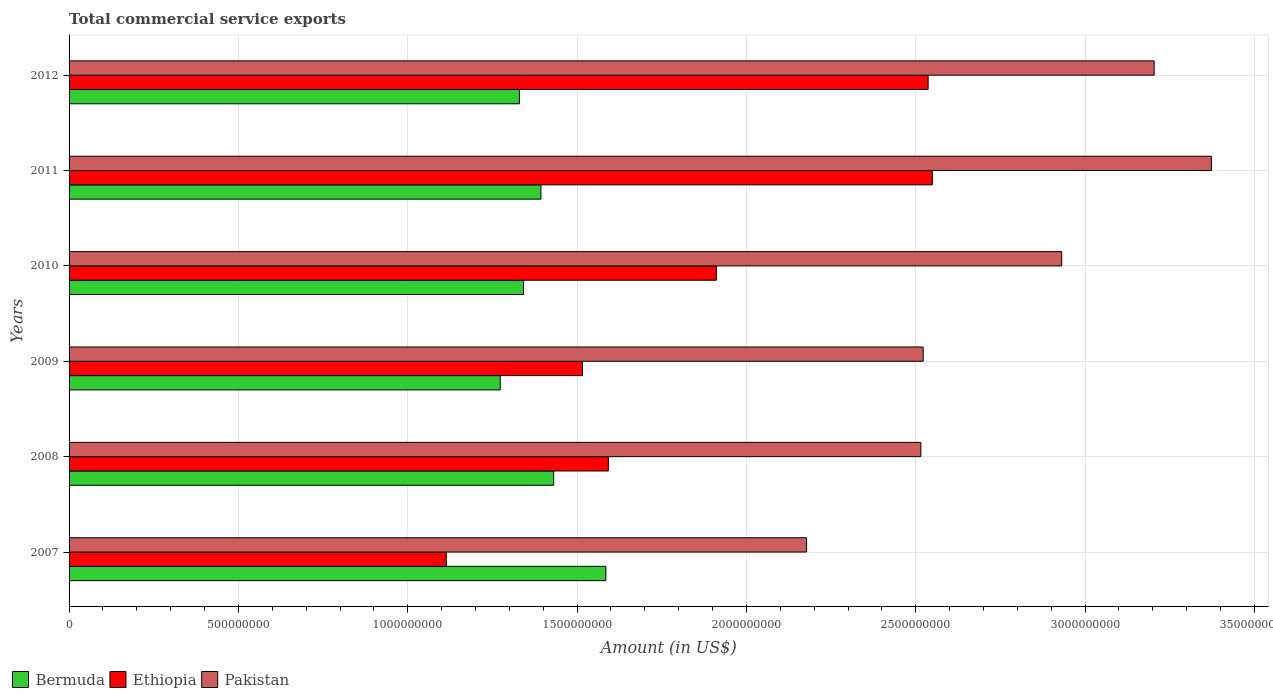How many different coloured bars are there?
Make the answer very short. 3. Are the number of bars per tick equal to the number of legend labels?
Your response must be concise. Yes. How many bars are there on the 2nd tick from the bottom?
Your response must be concise. 3. In how many cases, is the number of bars for a given year not equal to the number of legend labels?
Keep it short and to the point. 0. What is the total commercial service exports in Ethiopia in 2012?
Your answer should be compact. 2.54e+09. Across all years, what is the maximum total commercial service exports in Ethiopia?
Your response must be concise. 2.55e+09. Across all years, what is the minimum total commercial service exports in Ethiopia?
Give a very brief answer. 1.11e+09. What is the total total commercial service exports in Bermuda in the graph?
Your answer should be very brief. 8.35e+09. What is the difference between the total commercial service exports in Bermuda in 2010 and that in 2012?
Provide a short and direct response. 1.20e+07. What is the difference between the total commercial service exports in Ethiopia in 2010 and the total commercial service exports in Pakistan in 2011?
Offer a very short reply. -1.46e+09. What is the average total commercial service exports in Pakistan per year?
Offer a very short reply. 2.79e+09. In the year 2008, what is the difference between the total commercial service exports in Ethiopia and total commercial service exports in Bermuda?
Provide a short and direct response. 1.62e+08. What is the ratio of the total commercial service exports in Bermuda in 2009 to that in 2010?
Make the answer very short. 0.95. Is the difference between the total commercial service exports in Ethiopia in 2008 and 2009 greater than the difference between the total commercial service exports in Bermuda in 2008 and 2009?
Offer a very short reply. No. What is the difference between the highest and the second highest total commercial service exports in Ethiopia?
Provide a succinct answer. 1.24e+07. What is the difference between the highest and the lowest total commercial service exports in Bermuda?
Your answer should be compact. 3.12e+08. What does the 2nd bar from the top in 2008 represents?
Provide a succinct answer. Ethiopia. How many bars are there?
Provide a succinct answer. 18. Are all the bars in the graph horizontal?
Give a very brief answer. Yes. What is the difference between two consecutive major ticks on the X-axis?
Ensure brevity in your answer.  5.00e+08. Are the values on the major ticks of X-axis written in scientific E-notation?
Provide a short and direct response. No. Does the graph contain grids?
Make the answer very short. Yes. Where does the legend appear in the graph?
Make the answer very short. Bottom left. What is the title of the graph?
Offer a very short reply. Total commercial service exports. What is the Amount (in US$) of Bermuda in 2007?
Make the answer very short. 1.58e+09. What is the Amount (in US$) of Ethiopia in 2007?
Your answer should be very brief. 1.11e+09. What is the Amount (in US$) of Pakistan in 2007?
Ensure brevity in your answer.  2.18e+09. What is the Amount (in US$) of Bermuda in 2008?
Give a very brief answer. 1.43e+09. What is the Amount (in US$) in Ethiopia in 2008?
Offer a terse response. 1.59e+09. What is the Amount (in US$) of Pakistan in 2008?
Make the answer very short. 2.52e+09. What is the Amount (in US$) in Bermuda in 2009?
Your answer should be very brief. 1.27e+09. What is the Amount (in US$) of Ethiopia in 2009?
Keep it short and to the point. 1.52e+09. What is the Amount (in US$) of Pakistan in 2009?
Provide a short and direct response. 2.52e+09. What is the Amount (in US$) of Bermuda in 2010?
Your response must be concise. 1.34e+09. What is the Amount (in US$) of Ethiopia in 2010?
Give a very brief answer. 1.91e+09. What is the Amount (in US$) in Pakistan in 2010?
Your answer should be compact. 2.93e+09. What is the Amount (in US$) of Bermuda in 2011?
Give a very brief answer. 1.39e+09. What is the Amount (in US$) in Ethiopia in 2011?
Give a very brief answer. 2.55e+09. What is the Amount (in US$) of Pakistan in 2011?
Make the answer very short. 3.37e+09. What is the Amount (in US$) in Bermuda in 2012?
Ensure brevity in your answer.  1.33e+09. What is the Amount (in US$) of Ethiopia in 2012?
Ensure brevity in your answer.  2.54e+09. What is the Amount (in US$) of Pakistan in 2012?
Your answer should be compact. 3.20e+09. Across all years, what is the maximum Amount (in US$) in Bermuda?
Your answer should be compact. 1.58e+09. Across all years, what is the maximum Amount (in US$) in Ethiopia?
Your response must be concise. 2.55e+09. Across all years, what is the maximum Amount (in US$) in Pakistan?
Your answer should be compact. 3.37e+09. Across all years, what is the minimum Amount (in US$) in Bermuda?
Provide a succinct answer. 1.27e+09. Across all years, what is the minimum Amount (in US$) in Ethiopia?
Offer a very short reply. 1.11e+09. Across all years, what is the minimum Amount (in US$) of Pakistan?
Your answer should be compact. 2.18e+09. What is the total Amount (in US$) of Bermuda in the graph?
Your answer should be very brief. 8.35e+09. What is the total Amount (in US$) of Ethiopia in the graph?
Make the answer very short. 1.12e+1. What is the total Amount (in US$) of Pakistan in the graph?
Make the answer very short. 1.67e+1. What is the difference between the Amount (in US$) in Bermuda in 2007 and that in 2008?
Ensure brevity in your answer.  1.54e+08. What is the difference between the Amount (in US$) of Ethiopia in 2007 and that in 2008?
Your answer should be very brief. -4.79e+08. What is the difference between the Amount (in US$) of Pakistan in 2007 and that in 2008?
Provide a succinct answer. -3.37e+08. What is the difference between the Amount (in US$) in Bermuda in 2007 and that in 2009?
Your response must be concise. 3.12e+08. What is the difference between the Amount (in US$) of Ethiopia in 2007 and that in 2009?
Your response must be concise. -4.02e+08. What is the difference between the Amount (in US$) of Pakistan in 2007 and that in 2009?
Provide a short and direct response. -3.44e+08. What is the difference between the Amount (in US$) in Bermuda in 2007 and that in 2010?
Offer a terse response. 2.43e+08. What is the difference between the Amount (in US$) in Ethiopia in 2007 and that in 2010?
Your answer should be compact. -7.98e+08. What is the difference between the Amount (in US$) in Pakistan in 2007 and that in 2010?
Offer a terse response. -7.53e+08. What is the difference between the Amount (in US$) in Bermuda in 2007 and that in 2011?
Offer a terse response. 1.92e+08. What is the difference between the Amount (in US$) in Ethiopia in 2007 and that in 2011?
Offer a terse response. -1.44e+09. What is the difference between the Amount (in US$) in Pakistan in 2007 and that in 2011?
Make the answer very short. -1.20e+09. What is the difference between the Amount (in US$) in Bermuda in 2007 and that in 2012?
Provide a short and direct response. 2.55e+08. What is the difference between the Amount (in US$) of Ethiopia in 2007 and that in 2012?
Provide a succinct answer. -1.42e+09. What is the difference between the Amount (in US$) in Pakistan in 2007 and that in 2012?
Your response must be concise. -1.03e+09. What is the difference between the Amount (in US$) of Bermuda in 2008 and that in 2009?
Offer a very short reply. 1.58e+08. What is the difference between the Amount (in US$) of Ethiopia in 2008 and that in 2009?
Provide a succinct answer. 7.64e+07. What is the difference between the Amount (in US$) of Pakistan in 2008 and that in 2009?
Offer a terse response. -7.00e+06. What is the difference between the Amount (in US$) of Bermuda in 2008 and that in 2010?
Make the answer very short. 8.92e+07. What is the difference between the Amount (in US$) of Ethiopia in 2008 and that in 2010?
Your answer should be very brief. -3.19e+08. What is the difference between the Amount (in US$) of Pakistan in 2008 and that in 2010?
Ensure brevity in your answer.  -4.16e+08. What is the difference between the Amount (in US$) of Bermuda in 2008 and that in 2011?
Give a very brief answer. 3.77e+07. What is the difference between the Amount (in US$) in Ethiopia in 2008 and that in 2011?
Provide a succinct answer. -9.56e+08. What is the difference between the Amount (in US$) of Pakistan in 2008 and that in 2011?
Your answer should be compact. -8.58e+08. What is the difference between the Amount (in US$) of Bermuda in 2008 and that in 2012?
Offer a very short reply. 1.01e+08. What is the difference between the Amount (in US$) of Ethiopia in 2008 and that in 2012?
Make the answer very short. -9.44e+08. What is the difference between the Amount (in US$) of Pakistan in 2008 and that in 2012?
Your response must be concise. -6.89e+08. What is the difference between the Amount (in US$) in Bermuda in 2009 and that in 2010?
Offer a terse response. -6.86e+07. What is the difference between the Amount (in US$) of Ethiopia in 2009 and that in 2010?
Offer a terse response. -3.95e+08. What is the difference between the Amount (in US$) of Pakistan in 2009 and that in 2010?
Your response must be concise. -4.09e+08. What is the difference between the Amount (in US$) of Bermuda in 2009 and that in 2011?
Make the answer very short. -1.20e+08. What is the difference between the Amount (in US$) in Ethiopia in 2009 and that in 2011?
Your answer should be compact. -1.03e+09. What is the difference between the Amount (in US$) in Pakistan in 2009 and that in 2011?
Your answer should be compact. -8.51e+08. What is the difference between the Amount (in US$) in Bermuda in 2009 and that in 2012?
Your answer should be compact. -5.66e+07. What is the difference between the Amount (in US$) of Ethiopia in 2009 and that in 2012?
Offer a very short reply. -1.02e+09. What is the difference between the Amount (in US$) of Pakistan in 2009 and that in 2012?
Offer a very short reply. -6.82e+08. What is the difference between the Amount (in US$) of Bermuda in 2010 and that in 2011?
Offer a very short reply. -5.15e+07. What is the difference between the Amount (in US$) in Ethiopia in 2010 and that in 2011?
Provide a short and direct response. -6.38e+08. What is the difference between the Amount (in US$) in Pakistan in 2010 and that in 2011?
Your answer should be compact. -4.42e+08. What is the difference between the Amount (in US$) of Bermuda in 2010 and that in 2012?
Keep it short and to the point. 1.20e+07. What is the difference between the Amount (in US$) of Ethiopia in 2010 and that in 2012?
Offer a terse response. -6.25e+08. What is the difference between the Amount (in US$) of Pakistan in 2010 and that in 2012?
Provide a succinct answer. -2.73e+08. What is the difference between the Amount (in US$) in Bermuda in 2011 and that in 2012?
Your answer should be compact. 6.35e+07. What is the difference between the Amount (in US$) in Ethiopia in 2011 and that in 2012?
Your answer should be compact. 1.24e+07. What is the difference between the Amount (in US$) of Pakistan in 2011 and that in 2012?
Offer a terse response. 1.69e+08. What is the difference between the Amount (in US$) of Bermuda in 2007 and the Amount (in US$) of Ethiopia in 2008?
Offer a terse response. -7.48e+06. What is the difference between the Amount (in US$) of Bermuda in 2007 and the Amount (in US$) of Pakistan in 2008?
Provide a succinct answer. -9.30e+08. What is the difference between the Amount (in US$) in Ethiopia in 2007 and the Amount (in US$) in Pakistan in 2008?
Make the answer very short. -1.40e+09. What is the difference between the Amount (in US$) in Bermuda in 2007 and the Amount (in US$) in Ethiopia in 2009?
Provide a succinct answer. 6.90e+07. What is the difference between the Amount (in US$) in Bermuda in 2007 and the Amount (in US$) in Pakistan in 2009?
Your answer should be compact. -9.37e+08. What is the difference between the Amount (in US$) of Ethiopia in 2007 and the Amount (in US$) of Pakistan in 2009?
Ensure brevity in your answer.  -1.41e+09. What is the difference between the Amount (in US$) in Bermuda in 2007 and the Amount (in US$) in Ethiopia in 2010?
Ensure brevity in your answer.  -3.26e+08. What is the difference between the Amount (in US$) in Bermuda in 2007 and the Amount (in US$) in Pakistan in 2010?
Provide a succinct answer. -1.35e+09. What is the difference between the Amount (in US$) of Ethiopia in 2007 and the Amount (in US$) of Pakistan in 2010?
Keep it short and to the point. -1.82e+09. What is the difference between the Amount (in US$) of Bermuda in 2007 and the Amount (in US$) of Ethiopia in 2011?
Keep it short and to the point. -9.64e+08. What is the difference between the Amount (in US$) of Bermuda in 2007 and the Amount (in US$) of Pakistan in 2011?
Ensure brevity in your answer.  -1.79e+09. What is the difference between the Amount (in US$) of Ethiopia in 2007 and the Amount (in US$) of Pakistan in 2011?
Your response must be concise. -2.26e+09. What is the difference between the Amount (in US$) of Bermuda in 2007 and the Amount (in US$) of Ethiopia in 2012?
Your response must be concise. -9.52e+08. What is the difference between the Amount (in US$) in Bermuda in 2007 and the Amount (in US$) in Pakistan in 2012?
Your answer should be compact. -1.62e+09. What is the difference between the Amount (in US$) in Ethiopia in 2007 and the Amount (in US$) in Pakistan in 2012?
Ensure brevity in your answer.  -2.09e+09. What is the difference between the Amount (in US$) of Bermuda in 2008 and the Amount (in US$) of Ethiopia in 2009?
Ensure brevity in your answer.  -8.51e+07. What is the difference between the Amount (in US$) of Bermuda in 2008 and the Amount (in US$) of Pakistan in 2009?
Your answer should be very brief. -1.09e+09. What is the difference between the Amount (in US$) in Ethiopia in 2008 and the Amount (in US$) in Pakistan in 2009?
Provide a short and direct response. -9.30e+08. What is the difference between the Amount (in US$) of Bermuda in 2008 and the Amount (in US$) of Ethiopia in 2010?
Provide a succinct answer. -4.80e+08. What is the difference between the Amount (in US$) of Bermuda in 2008 and the Amount (in US$) of Pakistan in 2010?
Make the answer very short. -1.50e+09. What is the difference between the Amount (in US$) in Ethiopia in 2008 and the Amount (in US$) in Pakistan in 2010?
Your answer should be compact. -1.34e+09. What is the difference between the Amount (in US$) in Bermuda in 2008 and the Amount (in US$) in Ethiopia in 2011?
Give a very brief answer. -1.12e+09. What is the difference between the Amount (in US$) in Bermuda in 2008 and the Amount (in US$) in Pakistan in 2011?
Provide a succinct answer. -1.94e+09. What is the difference between the Amount (in US$) in Ethiopia in 2008 and the Amount (in US$) in Pakistan in 2011?
Your response must be concise. -1.78e+09. What is the difference between the Amount (in US$) in Bermuda in 2008 and the Amount (in US$) in Ethiopia in 2012?
Make the answer very short. -1.11e+09. What is the difference between the Amount (in US$) in Bermuda in 2008 and the Amount (in US$) in Pakistan in 2012?
Provide a succinct answer. -1.77e+09. What is the difference between the Amount (in US$) of Ethiopia in 2008 and the Amount (in US$) of Pakistan in 2012?
Give a very brief answer. -1.61e+09. What is the difference between the Amount (in US$) of Bermuda in 2009 and the Amount (in US$) of Ethiopia in 2010?
Your response must be concise. -6.38e+08. What is the difference between the Amount (in US$) of Bermuda in 2009 and the Amount (in US$) of Pakistan in 2010?
Provide a succinct answer. -1.66e+09. What is the difference between the Amount (in US$) in Ethiopia in 2009 and the Amount (in US$) in Pakistan in 2010?
Offer a terse response. -1.41e+09. What is the difference between the Amount (in US$) in Bermuda in 2009 and the Amount (in US$) in Ethiopia in 2011?
Provide a succinct answer. -1.28e+09. What is the difference between the Amount (in US$) of Bermuda in 2009 and the Amount (in US$) of Pakistan in 2011?
Offer a terse response. -2.10e+09. What is the difference between the Amount (in US$) in Ethiopia in 2009 and the Amount (in US$) in Pakistan in 2011?
Give a very brief answer. -1.86e+09. What is the difference between the Amount (in US$) in Bermuda in 2009 and the Amount (in US$) in Ethiopia in 2012?
Provide a short and direct response. -1.26e+09. What is the difference between the Amount (in US$) of Bermuda in 2009 and the Amount (in US$) of Pakistan in 2012?
Your response must be concise. -1.93e+09. What is the difference between the Amount (in US$) in Ethiopia in 2009 and the Amount (in US$) in Pakistan in 2012?
Provide a succinct answer. -1.69e+09. What is the difference between the Amount (in US$) in Bermuda in 2010 and the Amount (in US$) in Ethiopia in 2011?
Give a very brief answer. -1.21e+09. What is the difference between the Amount (in US$) of Bermuda in 2010 and the Amount (in US$) of Pakistan in 2011?
Give a very brief answer. -2.03e+09. What is the difference between the Amount (in US$) in Ethiopia in 2010 and the Amount (in US$) in Pakistan in 2011?
Offer a terse response. -1.46e+09. What is the difference between the Amount (in US$) of Bermuda in 2010 and the Amount (in US$) of Ethiopia in 2012?
Your answer should be compact. -1.19e+09. What is the difference between the Amount (in US$) of Bermuda in 2010 and the Amount (in US$) of Pakistan in 2012?
Provide a succinct answer. -1.86e+09. What is the difference between the Amount (in US$) of Ethiopia in 2010 and the Amount (in US$) of Pakistan in 2012?
Keep it short and to the point. -1.29e+09. What is the difference between the Amount (in US$) of Bermuda in 2011 and the Amount (in US$) of Ethiopia in 2012?
Offer a very short reply. -1.14e+09. What is the difference between the Amount (in US$) of Bermuda in 2011 and the Amount (in US$) of Pakistan in 2012?
Your answer should be very brief. -1.81e+09. What is the difference between the Amount (in US$) of Ethiopia in 2011 and the Amount (in US$) of Pakistan in 2012?
Keep it short and to the point. -6.55e+08. What is the average Amount (in US$) of Bermuda per year?
Your answer should be compact. 1.39e+09. What is the average Amount (in US$) of Ethiopia per year?
Give a very brief answer. 1.87e+09. What is the average Amount (in US$) of Pakistan per year?
Your answer should be very brief. 2.79e+09. In the year 2007, what is the difference between the Amount (in US$) of Bermuda and Amount (in US$) of Ethiopia?
Provide a succinct answer. 4.71e+08. In the year 2007, what is the difference between the Amount (in US$) of Bermuda and Amount (in US$) of Pakistan?
Your answer should be compact. -5.93e+08. In the year 2007, what is the difference between the Amount (in US$) in Ethiopia and Amount (in US$) in Pakistan?
Keep it short and to the point. -1.06e+09. In the year 2008, what is the difference between the Amount (in US$) of Bermuda and Amount (in US$) of Ethiopia?
Ensure brevity in your answer.  -1.62e+08. In the year 2008, what is the difference between the Amount (in US$) of Bermuda and Amount (in US$) of Pakistan?
Ensure brevity in your answer.  -1.08e+09. In the year 2008, what is the difference between the Amount (in US$) of Ethiopia and Amount (in US$) of Pakistan?
Give a very brief answer. -9.23e+08. In the year 2009, what is the difference between the Amount (in US$) in Bermuda and Amount (in US$) in Ethiopia?
Make the answer very short. -2.43e+08. In the year 2009, what is the difference between the Amount (in US$) of Bermuda and Amount (in US$) of Pakistan?
Give a very brief answer. -1.25e+09. In the year 2009, what is the difference between the Amount (in US$) of Ethiopia and Amount (in US$) of Pakistan?
Offer a very short reply. -1.01e+09. In the year 2010, what is the difference between the Amount (in US$) in Bermuda and Amount (in US$) in Ethiopia?
Provide a short and direct response. -5.70e+08. In the year 2010, what is the difference between the Amount (in US$) in Bermuda and Amount (in US$) in Pakistan?
Provide a succinct answer. -1.59e+09. In the year 2010, what is the difference between the Amount (in US$) in Ethiopia and Amount (in US$) in Pakistan?
Offer a very short reply. -1.02e+09. In the year 2011, what is the difference between the Amount (in US$) of Bermuda and Amount (in US$) of Ethiopia?
Make the answer very short. -1.16e+09. In the year 2011, what is the difference between the Amount (in US$) in Bermuda and Amount (in US$) in Pakistan?
Make the answer very short. -1.98e+09. In the year 2011, what is the difference between the Amount (in US$) of Ethiopia and Amount (in US$) of Pakistan?
Offer a very short reply. -8.24e+08. In the year 2012, what is the difference between the Amount (in US$) of Bermuda and Amount (in US$) of Ethiopia?
Give a very brief answer. -1.21e+09. In the year 2012, what is the difference between the Amount (in US$) of Bermuda and Amount (in US$) of Pakistan?
Your answer should be compact. -1.87e+09. In the year 2012, what is the difference between the Amount (in US$) of Ethiopia and Amount (in US$) of Pakistan?
Your answer should be very brief. -6.67e+08. What is the ratio of the Amount (in US$) of Bermuda in 2007 to that in 2008?
Provide a short and direct response. 1.11. What is the ratio of the Amount (in US$) in Ethiopia in 2007 to that in 2008?
Your answer should be very brief. 0.7. What is the ratio of the Amount (in US$) of Pakistan in 2007 to that in 2008?
Give a very brief answer. 0.87. What is the ratio of the Amount (in US$) of Bermuda in 2007 to that in 2009?
Make the answer very short. 1.25. What is the ratio of the Amount (in US$) in Ethiopia in 2007 to that in 2009?
Give a very brief answer. 0.73. What is the ratio of the Amount (in US$) in Pakistan in 2007 to that in 2009?
Your response must be concise. 0.86. What is the ratio of the Amount (in US$) of Bermuda in 2007 to that in 2010?
Your response must be concise. 1.18. What is the ratio of the Amount (in US$) in Ethiopia in 2007 to that in 2010?
Provide a short and direct response. 0.58. What is the ratio of the Amount (in US$) of Pakistan in 2007 to that in 2010?
Keep it short and to the point. 0.74. What is the ratio of the Amount (in US$) in Bermuda in 2007 to that in 2011?
Offer a very short reply. 1.14. What is the ratio of the Amount (in US$) of Ethiopia in 2007 to that in 2011?
Provide a succinct answer. 0.44. What is the ratio of the Amount (in US$) in Pakistan in 2007 to that in 2011?
Your answer should be very brief. 0.65. What is the ratio of the Amount (in US$) in Bermuda in 2007 to that in 2012?
Your response must be concise. 1.19. What is the ratio of the Amount (in US$) of Ethiopia in 2007 to that in 2012?
Offer a terse response. 0.44. What is the ratio of the Amount (in US$) of Pakistan in 2007 to that in 2012?
Offer a terse response. 0.68. What is the ratio of the Amount (in US$) in Bermuda in 2008 to that in 2009?
Provide a succinct answer. 1.12. What is the ratio of the Amount (in US$) of Ethiopia in 2008 to that in 2009?
Keep it short and to the point. 1.05. What is the ratio of the Amount (in US$) in Pakistan in 2008 to that in 2009?
Ensure brevity in your answer.  1. What is the ratio of the Amount (in US$) of Bermuda in 2008 to that in 2010?
Your answer should be very brief. 1.07. What is the ratio of the Amount (in US$) in Ethiopia in 2008 to that in 2010?
Offer a very short reply. 0.83. What is the ratio of the Amount (in US$) in Pakistan in 2008 to that in 2010?
Offer a very short reply. 0.86. What is the ratio of the Amount (in US$) in Bermuda in 2008 to that in 2011?
Make the answer very short. 1.03. What is the ratio of the Amount (in US$) in Ethiopia in 2008 to that in 2011?
Ensure brevity in your answer.  0.62. What is the ratio of the Amount (in US$) in Pakistan in 2008 to that in 2011?
Your answer should be very brief. 0.75. What is the ratio of the Amount (in US$) in Bermuda in 2008 to that in 2012?
Provide a short and direct response. 1.08. What is the ratio of the Amount (in US$) of Ethiopia in 2008 to that in 2012?
Give a very brief answer. 0.63. What is the ratio of the Amount (in US$) of Pakistan in 2008 to that in 2012?
Ensure brevity in your answer.  0.79. What is the ratio of the Amount (in US$) of Bermuda in 2009 to that in 2010?
Ensure brevity in your answer.  0.95. What is the ratio of the Amount (in US$) in Ethiopia in 2009 to that in 2010?
Make the answer very short. 0.79. What is the ratio of the Amount (in US$) in Pakistan in 2009 to that in 2010?
Give a very brief answer. 0.86. What is the ratio of the Amount (in US$) in Bermuda in 2009 to that in 2011?
Ensure brevity in your answer.  0.91. What is the ratio of the Amount (in US$) of Ethiopia in 2009 to that in 2011?
Provide a succinct answer. 0.59. What is the ratio of the Amount (in US$) in Pakistan in 2009 to that in 2011?
Your answer should be very brief. 0.75. What is the ratio of the Amount (in US$) in Bermuda in 2009 to that in 2012?
Provide a short and direct response. 0.96. What is the ratio of the Amount (in US$) of Ethiopia in 2009 to that in 2012?
Give a very brief answer. 0.6. What is the ratio of the Amount (in US$) of Pakistan in 2009 to that in 2012?
Make the answer very short. 0.79. What is the ratio of the Amount (in US$) of Ethiopia in 2010 to that in 2011?
Provide a short and direct response. 0.75. What is the ratio of the Amount (in US$) in Pakistan in 2010 to that in 2011?
Give a very brief answer. 0.87. What is the ratio of the Amount (in US$) in Ethiopia in 2010 to that in 2012?
Ensure brevity in your answer.  0.75. What is the ratio of the Amount (in US$) of Pakistan in 2010 to that in 2012?
Make the answer very short. 0.91. What is the ratio of the Amount (in US$) in Bermuda in 2011 to that in 2012?
Offer a very short reply. 1.05. What is the ratio of the Amount (in US$) in Pakistan in 2011 to that in 2012?
Provide a short and direct response. 1.05. What is the difference between the highest and the second highest Amount (in US$) in Bermuda?
Ensure brevity in your answer.  1.54e+08. What is the difference between the highest and the second highest Amount (in US$) in Ethiopia?
Offer a very short reply. 1.24e+07. What is the difference between the highest and the second highest Amount (in US$) of Pakistan?
Provide a short and direct response. 1.69e+08. What is the difference between the highest and the lowest Amount (in US$) in Bermuda?
Provide a short and direct response. 3.12e+08. What is the difference between the highest and the lowest Amount (in US$) of Ethiopia?
Offer a very short reply. 1.44e+09. What is the difference between the highest and the lowest Amount (in US$) in Pakistan?
Offer a very short reply. 1.20e+09. 